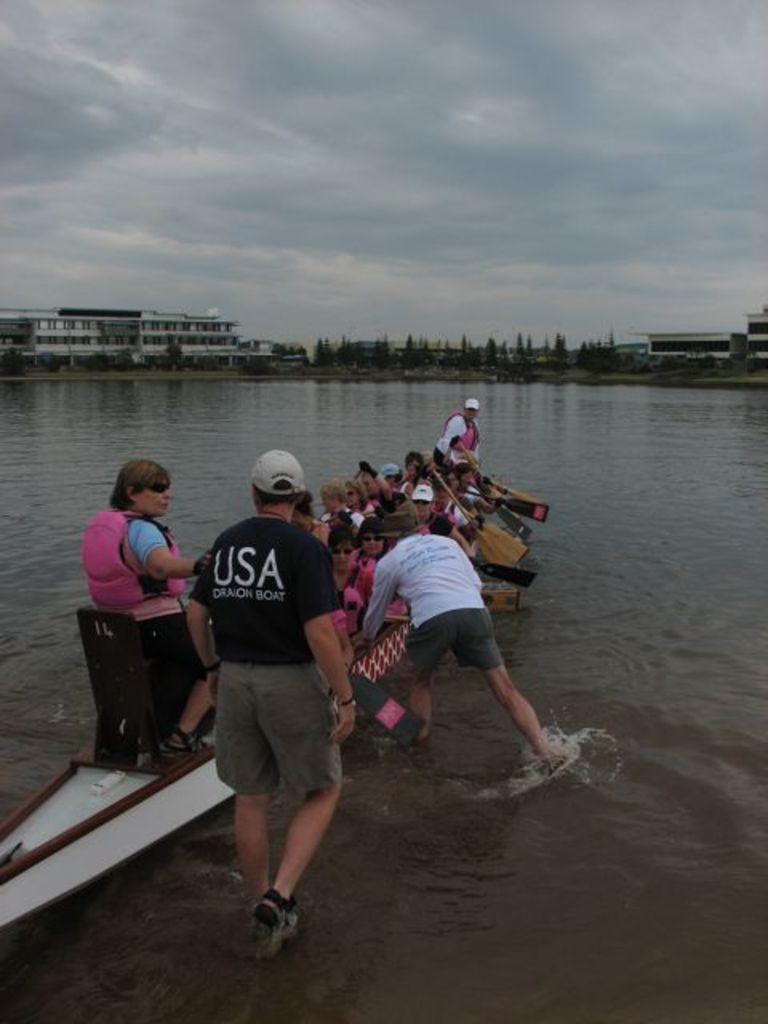Can you describe this image briefly? There are people on a boat and these two people in motion and we can see water and paddles. In the background we can see trees,buildings and sky. 